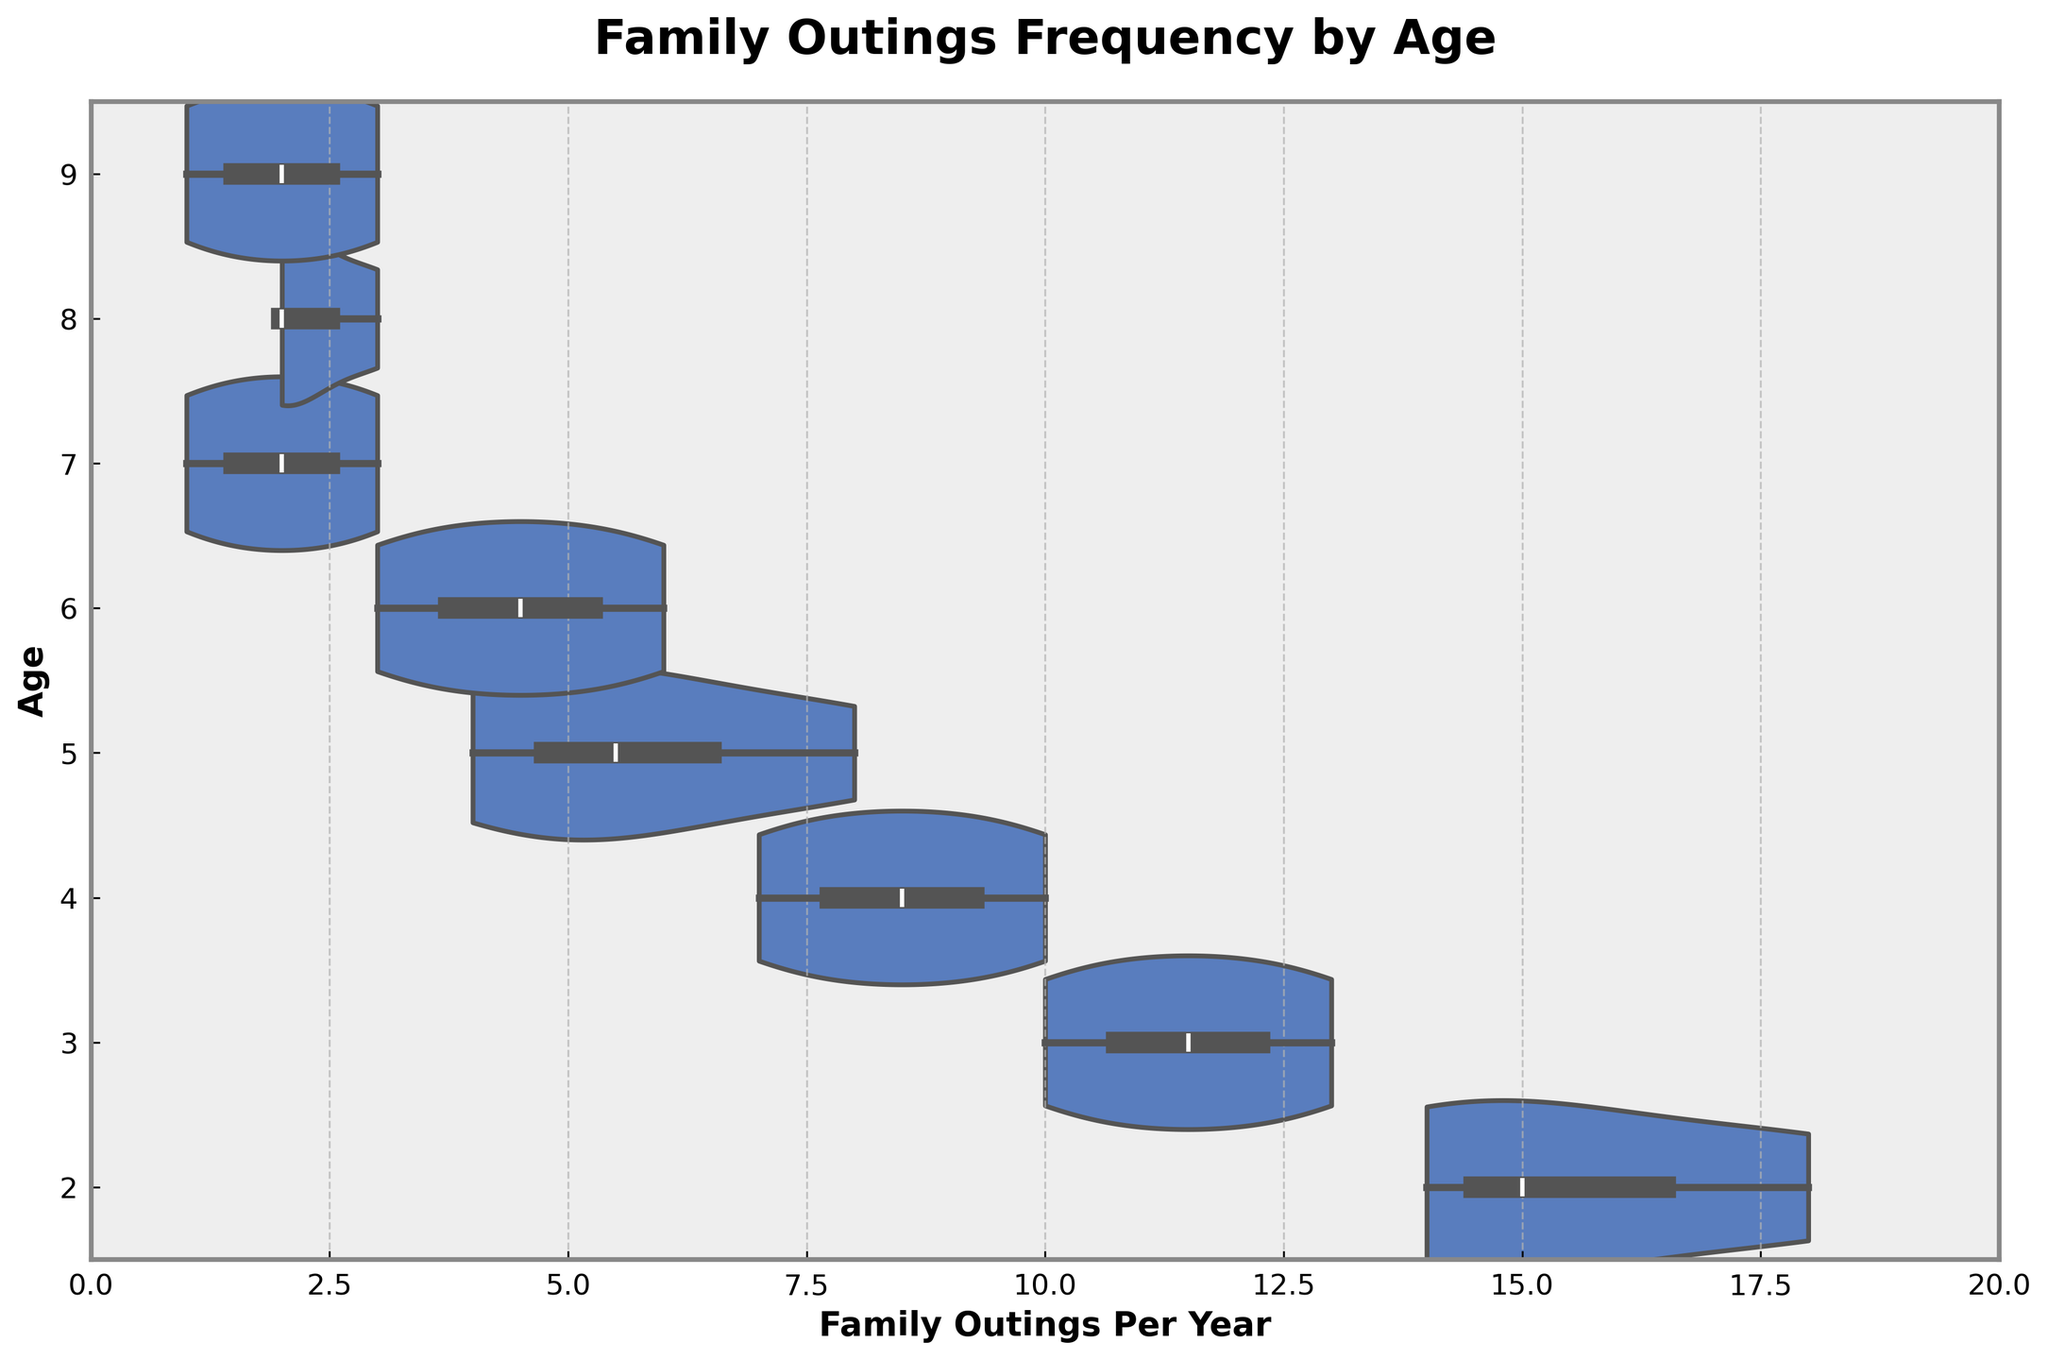What does the title of the chart indicate? The title of the chart, "Family Outings Frequency by Age," indicates that the plot displays the variation in the number of family outings per year across different ages.
Answer: Family Outings Frequency by Age What is the range of values for family outings per year indicated on the x-axis? The x-axis has the label "Family Outings Per Year" and the range is set from 0 to the maximum value found in the dataset plus 2. The highest value in the data is 18, so the range goes from 0 to 20.
Answer: 0 to 20 Which age group has the highest median number of family outings per year? The horizontal violin plot visually summarizes the distribution of family outings for each age group. By looking at the plots, we can identify that the age group 2 has the highest median value, as its box plot segment is located highest within the violin shape.
Answer: Age 2 How does the frequency of family outings change as age increases from 2 to 9? By observing the violin plots for each age group, it is clear that the median and spread of family outings decrease as age increases. The plots for younger ages (2-4) show higher medians and larger spreads, indicating more frequent outings. As the age increases to 9, the median value lowers, reflecting fewer outings.
Answer: Decreases Which age group shows the smallest variation in family outings frequency? Variation within an age group can be identified by the width of each violin plot. The plot for age 9 is the narrowest, indicating the smallest variation in the number of family outings per year.
Answer: Age 9 Are there any age groups where the median number of family outings is the same? By comparing the box plots within each violin shape, we see that ages 8 and 9 both have the same median value, represented by the line inside the box plot segment.
Answer: Ages 8 and 9 Which two age groups have the closest lower quartile values? The lower quartile values are represented by the bottom edge of the box plot segments within each violin plot. Ages 5 and 6 have the lower quartile values that are closest to each other.
Answer: Ages 5 and 6 What is the median number of family outings for age 5? By looking at the box plot within the violin shape for age 5, the median value is the line inside the box. For age 5, it is about 6 outings per year.
Answer: 6 outings per year Which age has the widest range of family outings per year? The range of family outings can be judged by the overall length of the violin plot shape along the x-axis. Age 2 has the widest range of family outings, ranging from as low as 14 to as high as 18.
Answer: Age 2 What is the general trend observed in the data? By examining the median values and the distribution of the data for each age, there is a clear decreasing trend in the frequency of family outings as children increase in age from 2 to 9.
Answer: Decreasing trend 